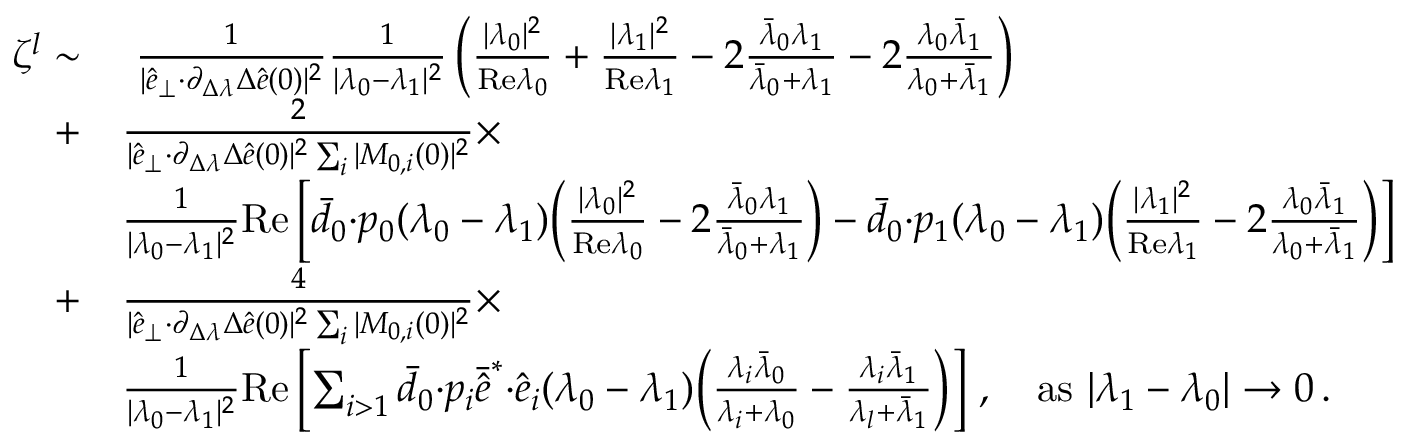<formula> <loc_0><loc_0><loc_500><loc_500>\begin{array} { r l } { \zeta ^ { l } \sim } & { \frac { 1 } { | \hat { e } _ { \perp } { \cdot } \partial _ { \Delta \lambda } \Delta \hat { e } ( 0 ) | ^ { 2 } } \frac { 1 } { | \lambda _ { 0 } - \lambda _ { 1 } | ^ { 2 } } \left ( \frac { | \lambda _ { 0 } | ^ { 2 } } { R e \lambda _ { 0 } } + \frac { | \lambda _ { 1 } | ^ { 2 } } { R e \lambda _ { 1 } } - 2 \frac { \bar { \lambda } _ { 0 } \lambda _ { 1 } } { \bar { \lambda } _ { 0 } + \lambda _ { 1 } } - 2 \frac { \lambda _ { 0 } \bar { \lambda } _ { 1 } } { \lambda _ { 0 } + \bar { \lambda } _ { 1 } } \right ) } \\ { + } & { \frac { 2 } { | \hat { e } _ { \perp } { \cdot } \partial _ { \Delta \lambda } \Delta \hat { e } ( 0 ) | ^ { 2 } \sum _ { i } | M _ { 0 , i } ( 0 ) | ^ { 2 } } \times } \\ & { \frac { 1 } { | \lambda _ { 0 } - \lambda _ { 1 } | ^ { 2 } } R e \left [ \bar { d } _ { 0 } { \cdot } p _ { 0 } ( \lambda _ { 0 } - \lambda _ { 1 } ) \left ( \frac { | \lambda _ { 0 } | ^ { 2 } } { R e \lambda _ { 0 } } - 2 \frac { \bar { \lambda } _ { 0 } \lambda _ { 1 } } { \bar { \lambda } _ { 0 } + \lambda _ { 1 } } \right ) - \bar { d } _ { 0 } { \cdot } p _ { 1 } ( \lambda _ { 0 } - \lambda _ { 1 } ) \left ( \frac { | \lambda _ { 1 } | ^ { 2 } } { R e \lambda _ { 1 } } - 2 \frac { \lambda _ { 0 } \bar { \lambda } _ { 1 } } { \lambda _ { 0 } + \bar { \lambda } _ { 1 } } \right ) \right ] } \\ { + } & { \frac { 4 } { | \hat { e } _ { \perp } { \cdot } \partial _ { \Delta \lambda } \Delta \hat { e } ( 0 ) | ^ { 2 } \sum _ { i } | M _ { 0 , i } ( 0 ) | ^ { 2 } } \times } \\ & { \frac { 1 } { | \lambda _ { 0 } - \lambda _ { 1 } | ^ { 2 } } R e \left [ \sum _ { i > 1 } \bar { d } _ { 0 } { \cdot } p _ { i } \bar { \hat { e } } ^ { * } { \cdot } \hat { e } _ { i } ( \lambda _ { 0 } - \lambda _ { 1 } ) \left ( \frac { \lambda _ { i } \bar { \lambda } _ { 0 } } { \lambda _ { i } + \lambda _ { 0 } } - \frac { \lambda _ { i } \bar { \lambda } _ { 1 } } { \lambda _ { l } + \bar { \lambda } _ { 1 } } \right ) \right ] \, , a s | \lambda _ { 1 } - \lambda _ { 0 } | \rightarrow 0 \, . } \end{array}</formula> 